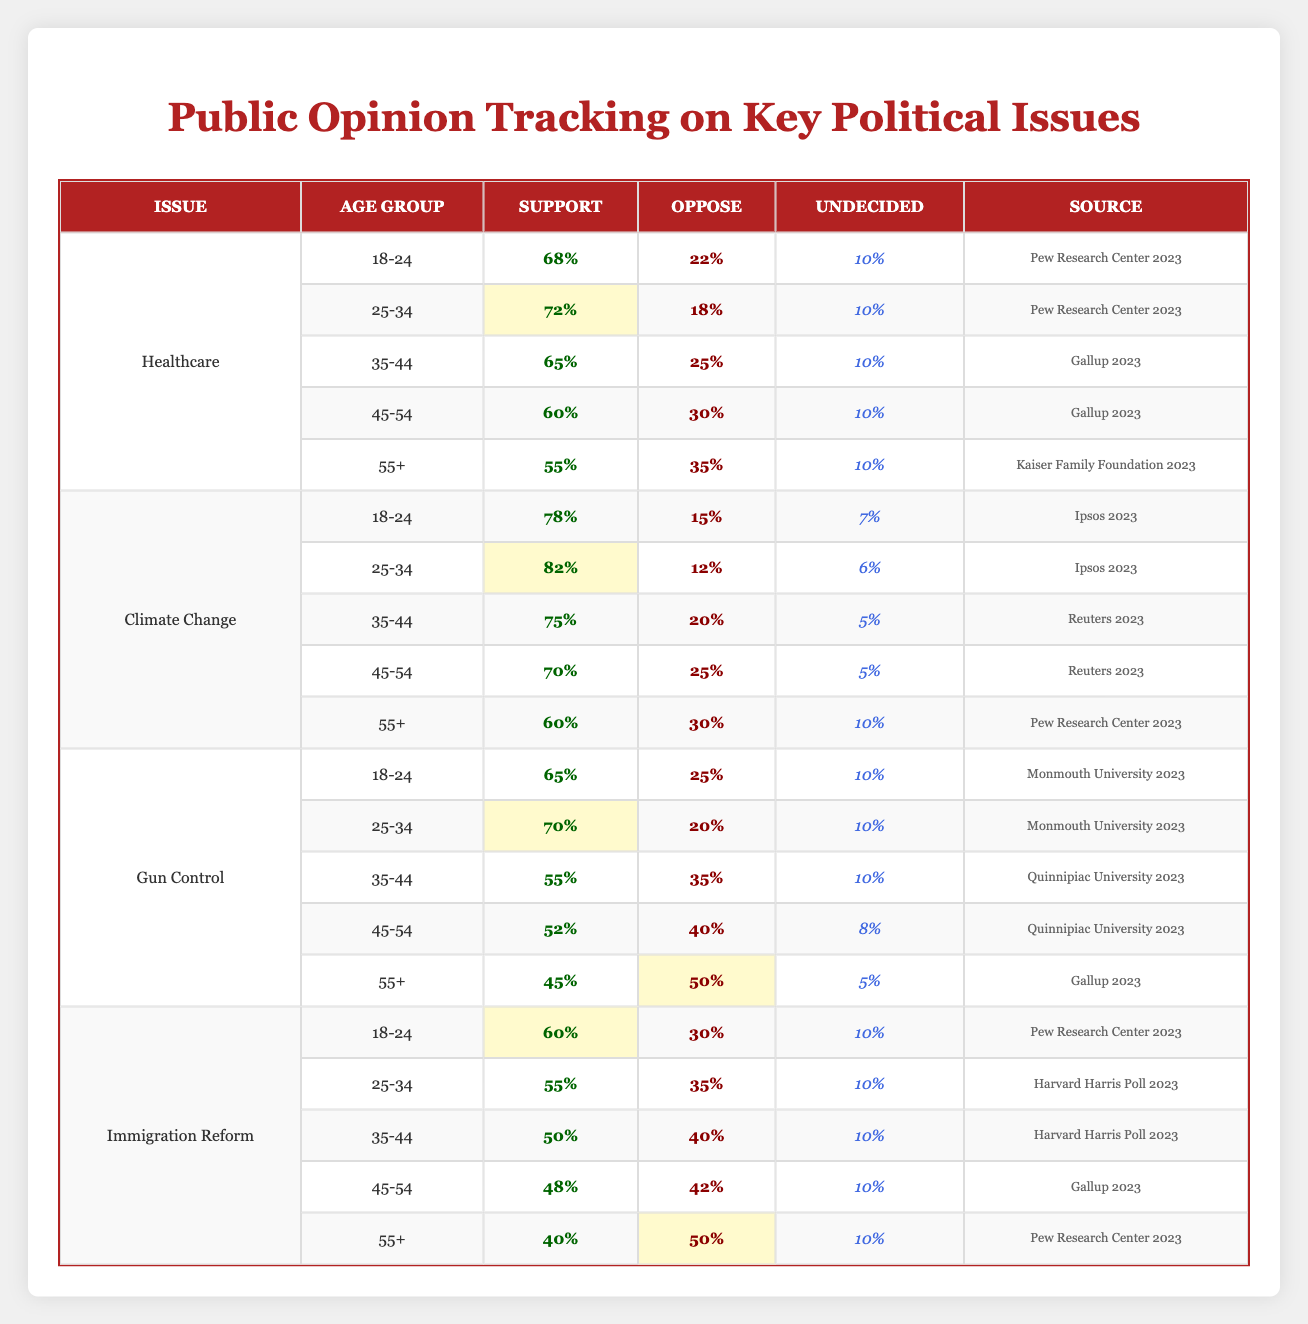What percentage of the 25-34 age group supports Healthcare? In the Healthcare section of the table, the support percentage for the 25-34 age group is listed directly. It shows that 72% support it.
Answer: 72% Which age group has the highest support for Climate Change? Looking at the Climate Change issue, the support for the age group 25-34 is 82%, which is the highest value in that section.
Answer: 25-34 Is there a higher percentage of support for Gun Control among the 18-24 age group compared to the 45-54 age group? For the 18-24 age group, the support is 65%, while for the 45-54 group, the support is 52%. Since 65% is greater than 52%, the answer is yes.
Answer: Yes What is the average support for Immigration Reform across all age groups? The support percentages for Immigration Reform are 60, 55, 50, 48, and 40. Adding these (60 + 55 + 50 + 48 + 40 = 253) means that the average is 253/5 = 50.6 (approximately 51).
Answer: 51 How does the support of individuals aged 55+ for Healthcare compare to their support for Climate Change? For Healthcare, support among 55+ is 55%, while for Climate Change, it is 60%. Since 60% is greater than 55%, Climate Change has more support from this age group.
Answer: Climate Change has more support Which issue has the largest percentage opposition among 45-54 year-olds? The table shows that for Gun Control, the opposition is 40%. The highest opposition among 45-54 year-olds found in other issues is 30% (Healthcare) or 25% (Climate Change). Thus, Gun Control has the largest opposition with 40%.
Answer: Gun Control What is the difference in undecided voters' percentages between the 18-24 age group for Climate Change and Gun Control? For Climate Change, the undecided percentage for the 18-24 group is 7%, and for Gun Control, it is 10%. The difference is 10% - 7% = 3%.
Answer: 3% Among the 35-44 age group, which issue has a higher support percentage, Gun Control or Immigration Reform? For the 35-44 age group, Gun Control has 55% support, while Immigration Reform has 50% support. Thus, Gun Control has higher support by a difference of 5%.
Answer: Gun Control Is the support for Climate Change among the 45-54 age group greater than the support for Healthcare in the same group? In the 45-54 age group, support for Climate Change is 70%, while for Healthcare it is 60%. Since 70% is greater than 60%, the answer is yes.
Answer: Yes 